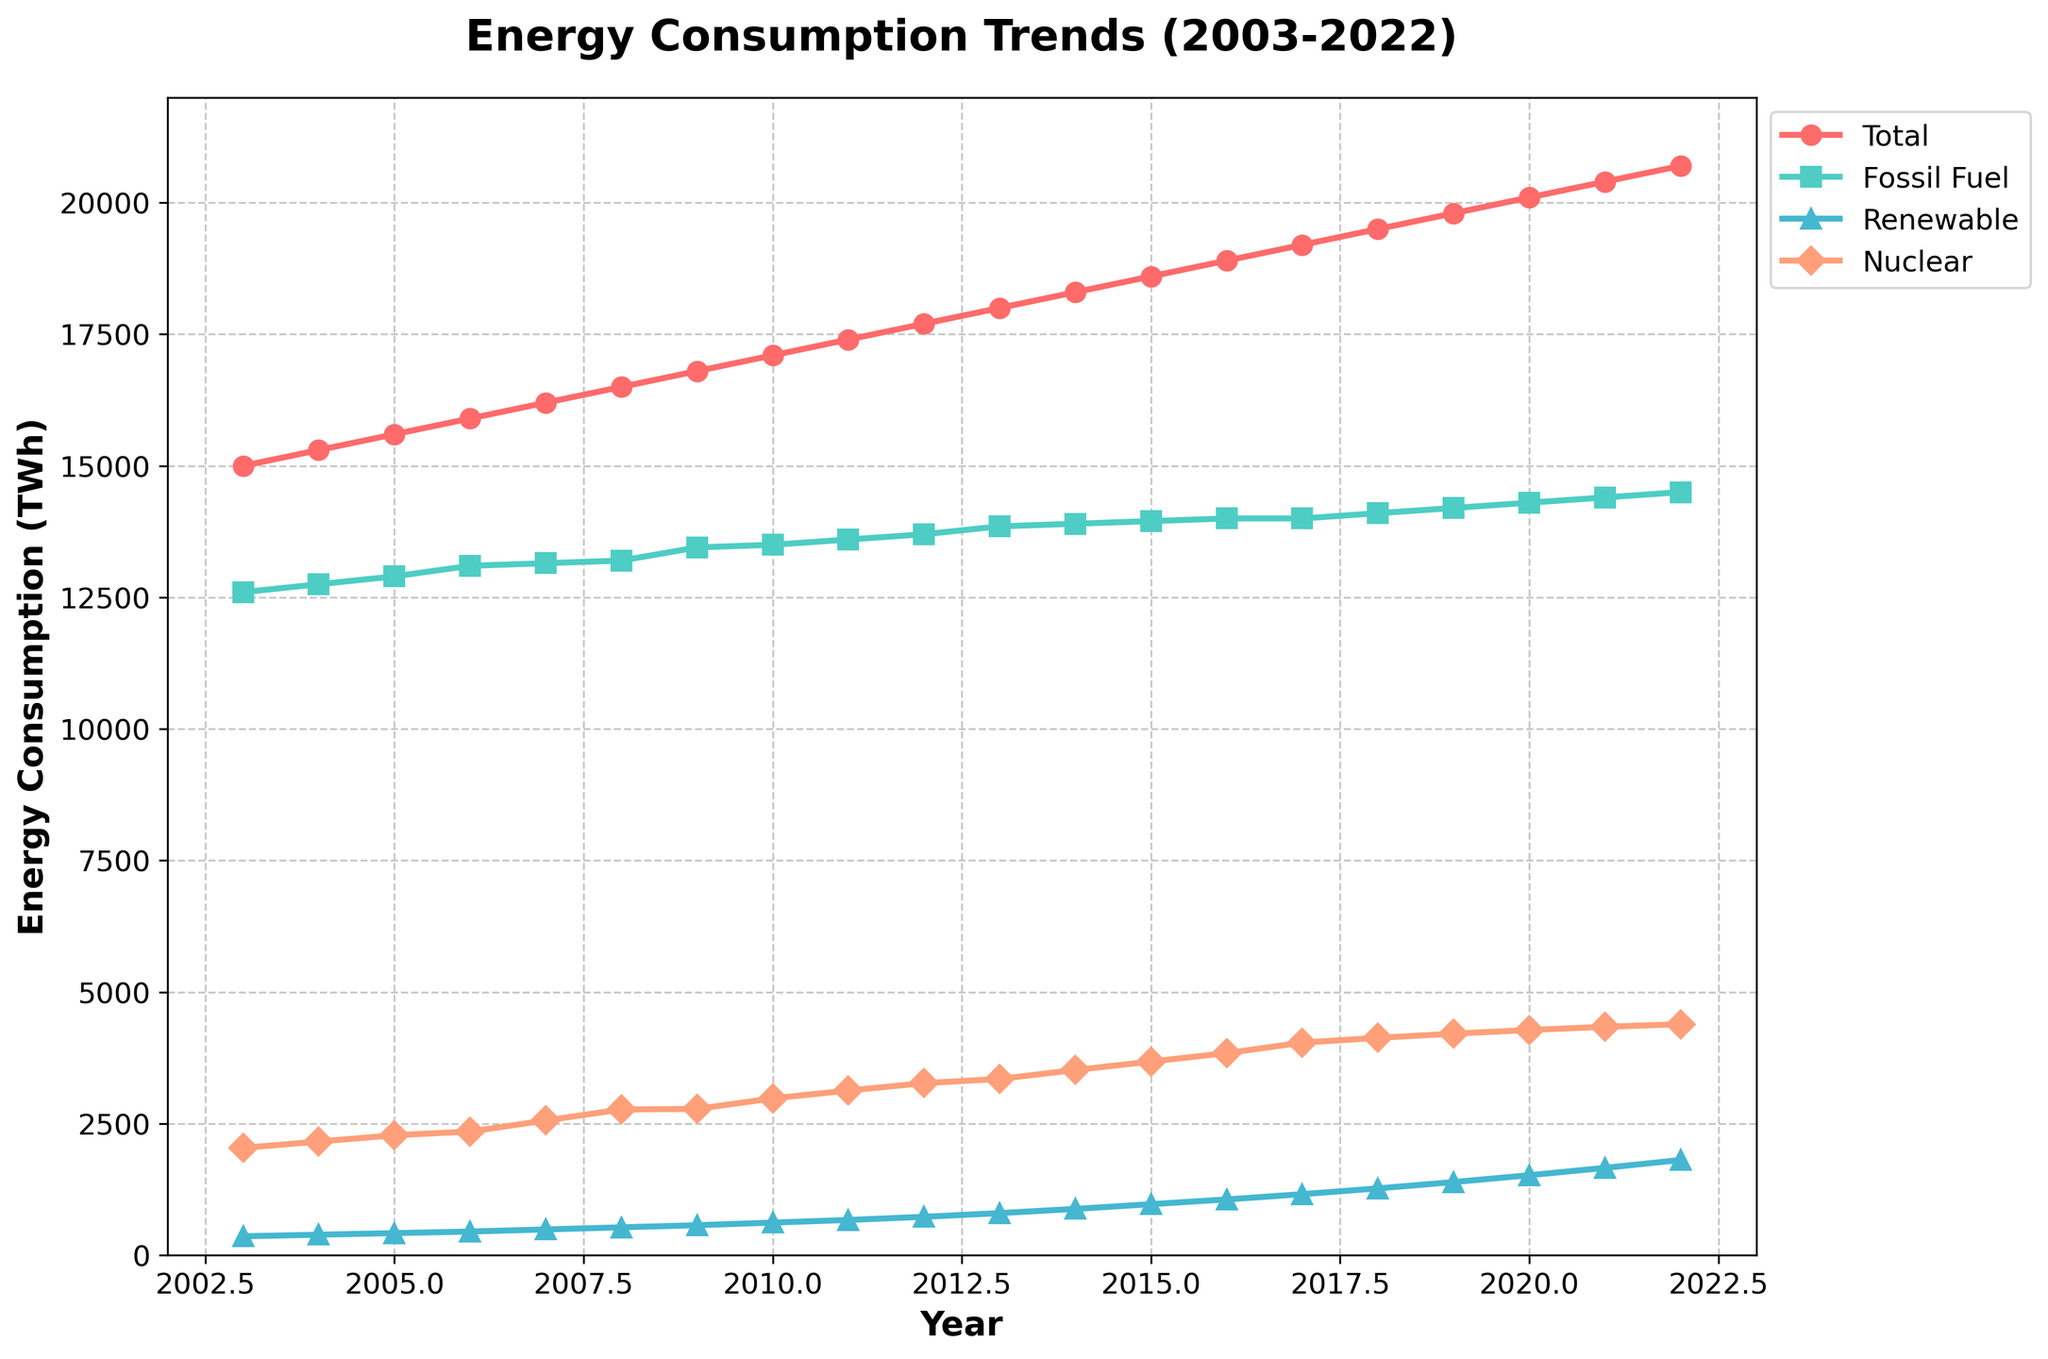What is the title of the plot? The title of the plot is displayed at the top and summarizes what the plot is about. The title is "Energy Consumption Trends (2003-2022)"
Answer: Energy Consumption Trends (2003-2022) What is the color used to represent Renewable Energy Consumption in the plot? By examining the plot legend, we can see that each energy type is represented by a different color. Renewable Energy Consumption is represented by the color cyan.
Answer: cyan Which year shows the highest Renewable Energy Consumption, and what is its value? By observing the trend line for Renewable Energy Consumption, the highest value can be found at the endpoint of this line. It peaks in 2022 with a value labeled on the vertical axis.
Answer: 2022, 1810 TWh Between which years did Renewable Energy Consumption see its first significant increase of more than 100 TWh? Look at the Renewable Energy Consumption line and find the first noticeable jump. The increase from 2008 to 2009 is from 530 TWh to 570 TWh, an increase of 40 TWh, which is less than 100 TWh. The first significant increase of more than 100 TWh occurs from 2014 (880 TWh) to 2015 (970 TWh).
Answer: 2014 to 2015 How does Fossil Fuel Energy Consumption in 2021 compare to that in 2003? Locate the value for Fossil Fuel Energy Consumption in 2003 and 2021 from the plot. In 2003 it is around 12,600 TWh, and in 2021, it is approximately 14,400 TWh. We then compare both values.
Answer: Increased by 1800 TWh In which year did Nuclear Energy Consumption surpass 4,000 TWh? Look at the Nuclear Energy Consumption line and find the year where the value first exceeds 4,000 TWh. This happens in 2017.
Answer: 2017 What is the trend in Total Energy Consumption from 2003 to 2022? Observe the Total Energy Consumption line over the entire span of years. It shows a consistent increasing trend from 2003 to 2022.
Answer: Increasing trend Which year had the smallest difference between Fossil Fuel Energy Consumption and Renewable Energy Consumption? By calculating the difference between Fossil Fuel Energy Consumption and Renewable Energy Consumption for each year and then identifying the smallest difference. This happens in 2022, where the difference is 12,690 TWh (14,500 TWh - 1810 TWh), the smallest compared to other years.
Answer: 2022 How did Nuclear Energy Consumption change from 2009 to 2012? Look at the Nuclear Energy Consumption values in 2009 (2780 TWh) and in 2012 (3270 TWh) and then calculate the change, which is 3270 - 2780 = 490 TWh.
Answer: Increased by 490 TWh 